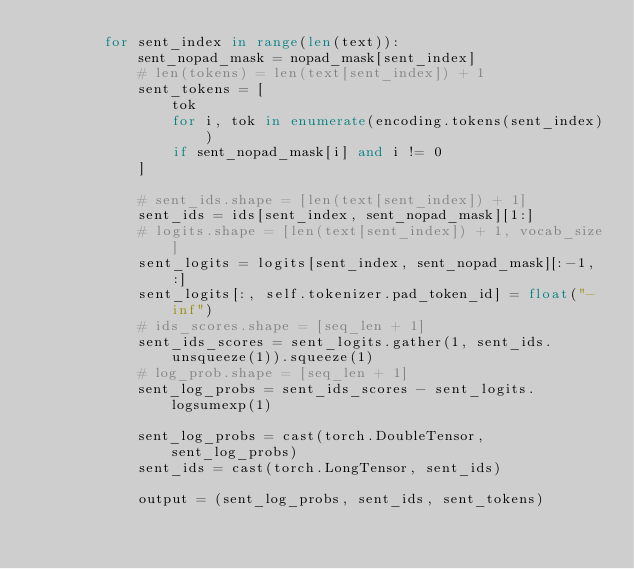<code> <loc_0><loc_0><loc_500><loc_500><_Python_>        for sent_index in range(len(text)):
            sent_nopad_mask = nopad_mask[sent_index]
            # len(tokens) = len(text[sent_index]) + 1
            sent_tokens = [
                tok
                for i, tok in enumerate(encoding.tokens(sent_index))
                if sent_nopad_mask[i] and i != 0
            ]

            # sent_ids.shape = [len(text[sent_index]) + 1]
            sent_ids = ids[sent_index, sent_nopad_mask][1:]
            # logits.shape = [len(text[sent_index]) + 1, vocab_size]
            sent_logits = logits[sent_index, sent_nopad_mask][:-1, :]
            sent_logits[:, self.tokenizer.pad_token_id] = float("-inf")
            # ids_scores.shape = [seq_len + 1]
            sent_ids_scores = sent_logits.gather(1, sent_ids.unsqueeze(1)).squeeze(1)
            # log_prob.shape = [seq_len + 1]
            sent_log_probs = sent_ids_scores - sent_logits.logsumexp(1)

            sent_log_probs = cast(torch.DoubleTensor, sent_log_probs)
            sent_ids = cast(torch.LongTensor, sent_ids)

            output = (sent_log_probs, sent_ids, sent_tokens)</code> 